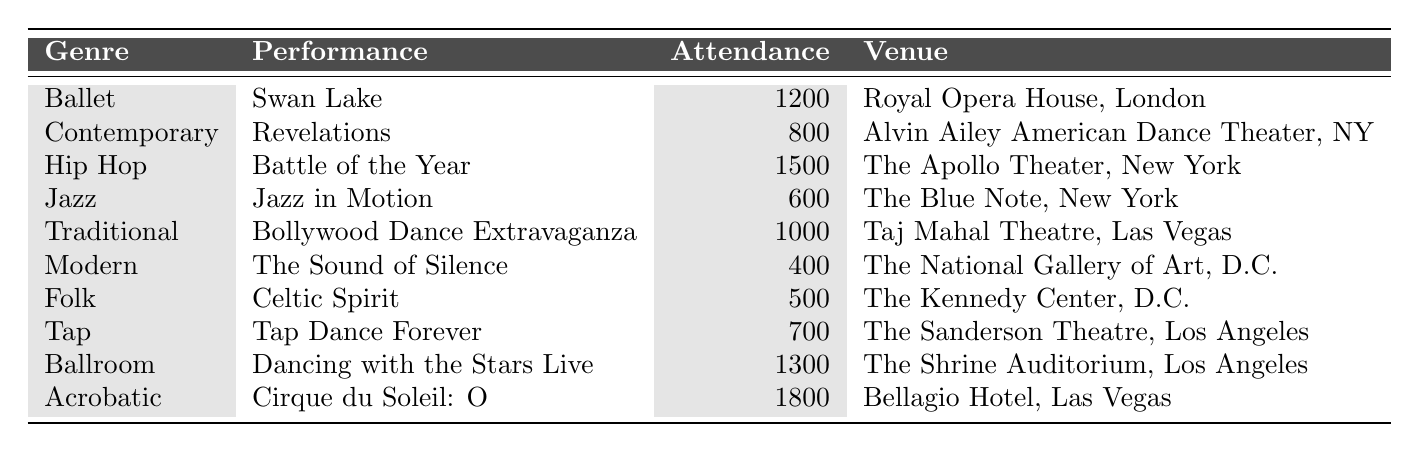What is the highest attendance recorded for a dance performance? The table shows various performances with their respective attendance numbers. The highest number listed is 1800 for the "Cirque du Soleil: O" performance.
Answer: 1800 Which genre had the lowest attendance? Looking at the attendance figures for each genre, "The Sound of Silence" in the Modern genre has the lowest attendance with 400.
Answer: Modern How many performances had an attendance of over 1000? The table lists the attendance for each performance. The performances with attendance over 1000 are "Cirque du Soleil: O", "Hip Hop: Battle of the Year", and "Ballroom: Dancing with the Stars Live", totaling 3 performances.
Answer: 3 What is the average attendance across all performances? To find the average, sum the attendance figures: 1200 + 800 + 1500 + 600 + 1000 + 400 + 500 + 700 + 1300 + 1800 = 6500. There are 10 performances, so the average is 6500/10 = 650.
Answer: 650 Did any performance reach an attendance of exactly 800? The table indicates that "Revelations" in the Contemporary genre had an attendance of 800, confirming that there was a performance with this exact attendance.
Answer: Yes How much higher is the attendance of the highest performance compared to the lowest? The highest attendance is 1800 (Cirque du Soleil: O) and the lowest is 400 (The Sound of Silence). The difference is 1800 - 400 = 1400.
Answer: 1400 Which performance had the highest attendance in New York? The table lists "Battle of the Year" in the Hip Hop genre with an attendance of 1500 as the highest attendance for performances located in New York.
Answer: Battle of the Year Was the attendance for "Dancing with the Stars Live" greater than that for "Bollywood Dance Extravaganza"? "Dancing with the Stars Live" had an attendance of 1300, while "Bollywood Dance Extravaganza" had 1000. Since 1300 > 1000, the attendance for "Dancing with the Stars Live" is indeed greater.
Answer: Yes What is the total attendance for performances in Las Vegas? Summing the attendance for Las Vegas performances: "Bollywood Dance Extravaganza" (1000) and "Cirque du Soleil: O" (1800), gives 1000 + 1800 = 2800.
Answer: 2800 Which genre had the highest attendance that is not acrobatic? The attendance for Acrobatic is 1800, but Hip Hop with "Battle of the Year" has 1500, which is the highest attendance among the remaining genres.
Answer: Hip Hop 